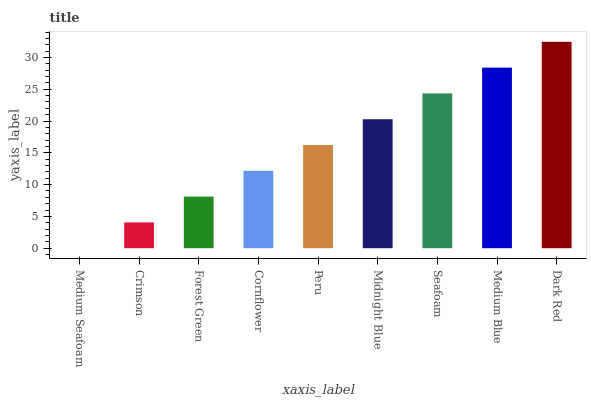Is Medium Seafoam the minimum?
Answer yes or no. Yes. Is Dark Red the maximum?
Answer yes or no. Yes. Is Crimson the minimum?
Answer yes or no. No. Is Crimson the maximum?
Answer yes or no. No. Is Crimson greater than Medium Seafoam?
Answer yes or no. Yes. Is Medium Seafoam less than Crimson?
Answer yes or no. Yes. Is Medium Seafoam greater than Crimson?
Answer yes or no. No. Is Crimson less than Medium Seafoam?
Answer yes or no. No. Is Peru the high median?
Answer yes or no. Yes. Is Peru the low median?
Answer yes or no. Yes. Is Seafoam the high median?
Answer yes or no. No. Is Forest Green the low median?
Answer yes or no. No. 